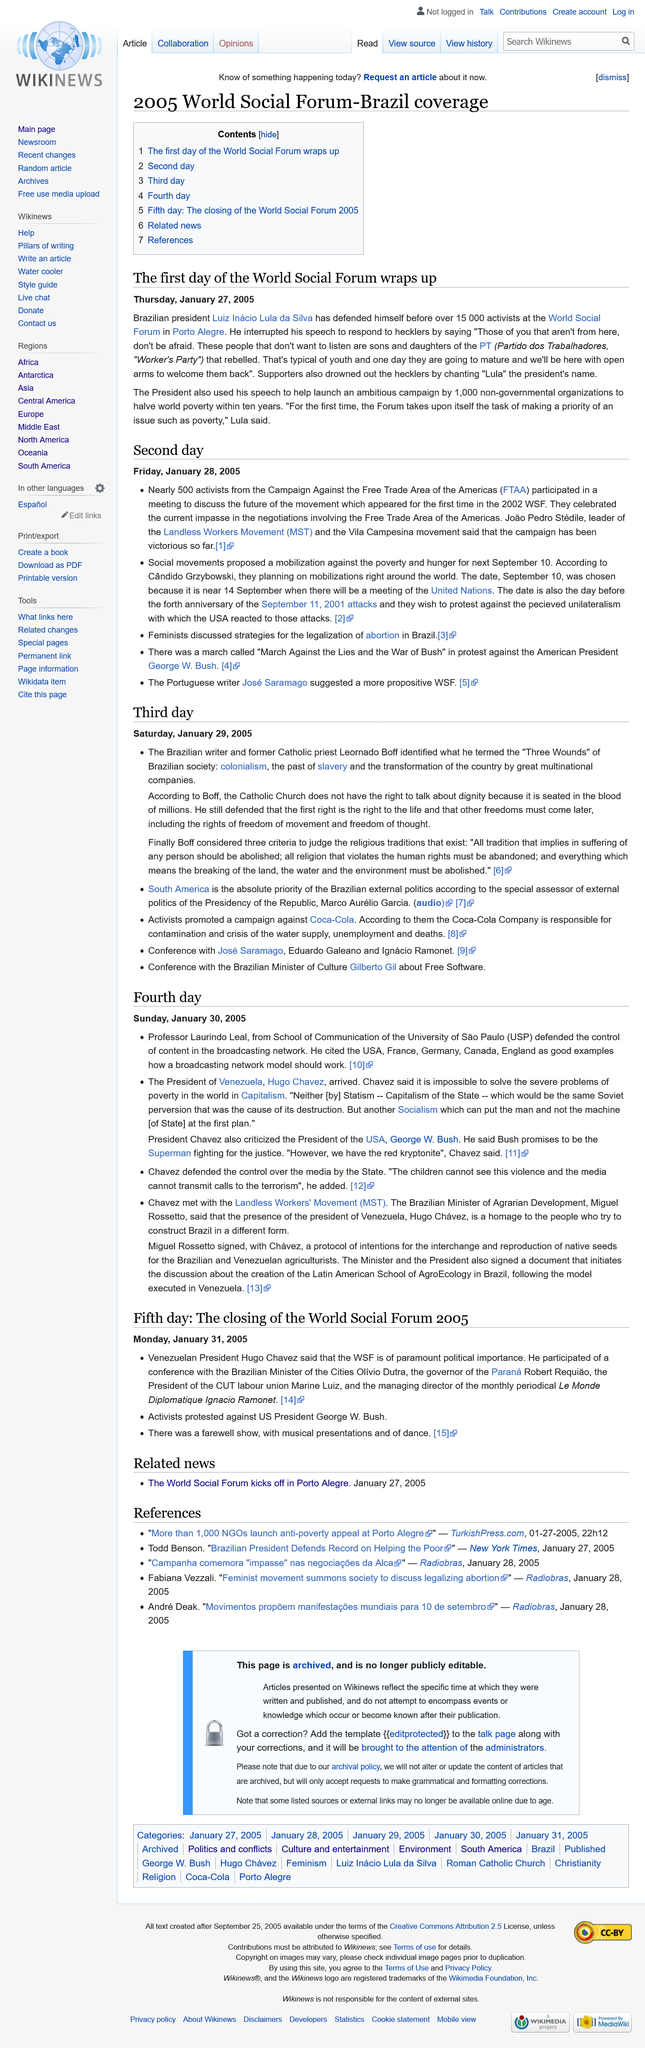Highlight a few significant elements in this photo. FTAA stands for the Free Trade Area of the Americas, which is a trade agreement among countries in the Americas for the promotion of free trade and economic integration. There was a farewell show on the fifth day of the World Social Forum 2005. WSF stands for the World Social Forum, which is a global event that brings together people and organizations from different countries and backgrounds to discuss and act on issues related to social justice and equity. The name of the current president of Brazil is Luiz Inácio Lula da Silva. Leonardo Boff, a Brazilian writer and former Catholic priest, asserts that the Catholic Church does not possess the authority to speak about dignity. 